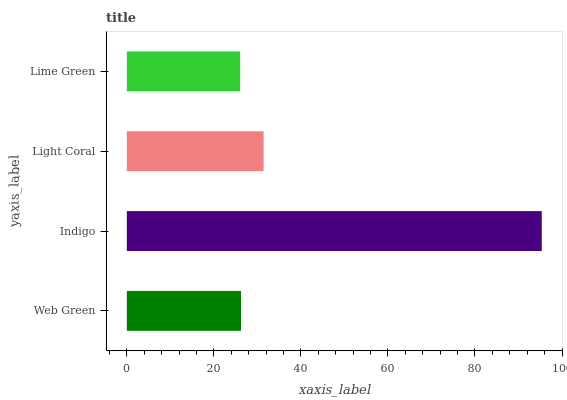Is Lime Green the minimum?
Answer yes or no. Yes. Is Indigo the maximum?
Answer yes or no. Yes. Is Light Coral the minimum?
Answer yes or no. No. Is Light Coral the maximum?
Answer yes or no. No. Is Indigo greater than Light Coral?
Answer yes or no. Yes. Is Light Coral less than Indigo?
Answer yes or no. Yes. Is Light Coral greater than Indigo?
Answer yes or no. No. Is Indigo less than Light Coral?
Answer yes or no. No. Is Light Coral the high median?
Answer yes or no. Yes. Is Web Green the low median?
Answer yes or no. Yes. Is Web Green the high median?
Answer yes or no. No. Is Lime Green the low median?
Answer yes or no. No. 